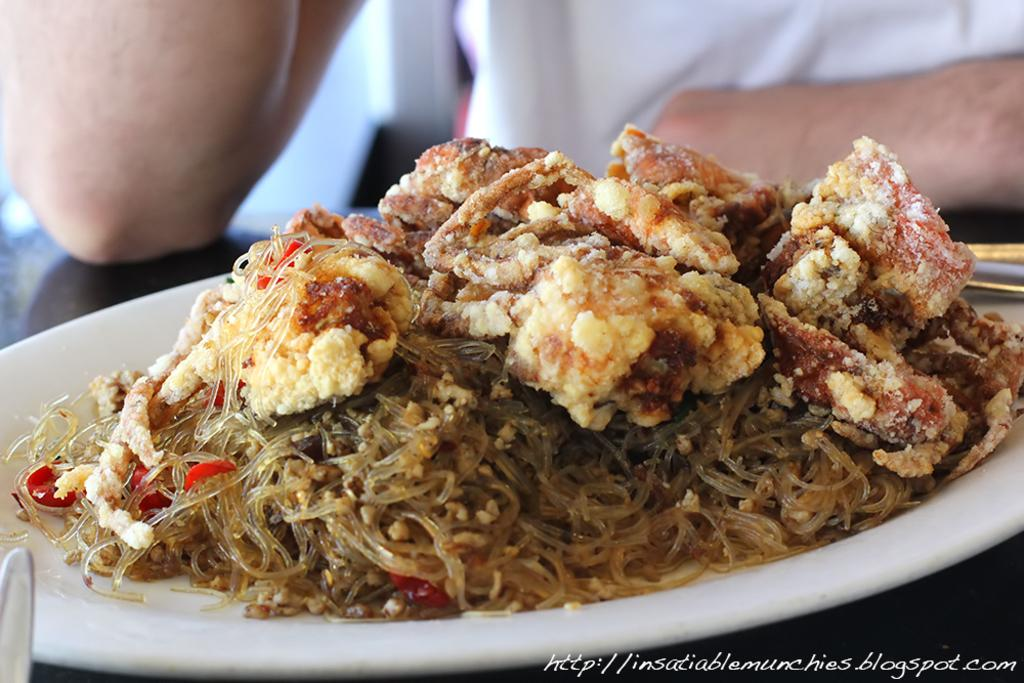What object is present on the table in the image? There is a plate on the table in the image. What is on the plate? There is food on the plate. What surface is the plate resting on? The plate is resting on a table. Whose hands are visible in the image? A person's hands are visible in the image. Can you describe any additional details about the image? There is a watermark at the bottom right side of the image. What type of wheel is being discussed in the meeting depicted in the image? There is no meeting depicted in the image, and therefore no discussion about a wheel. 